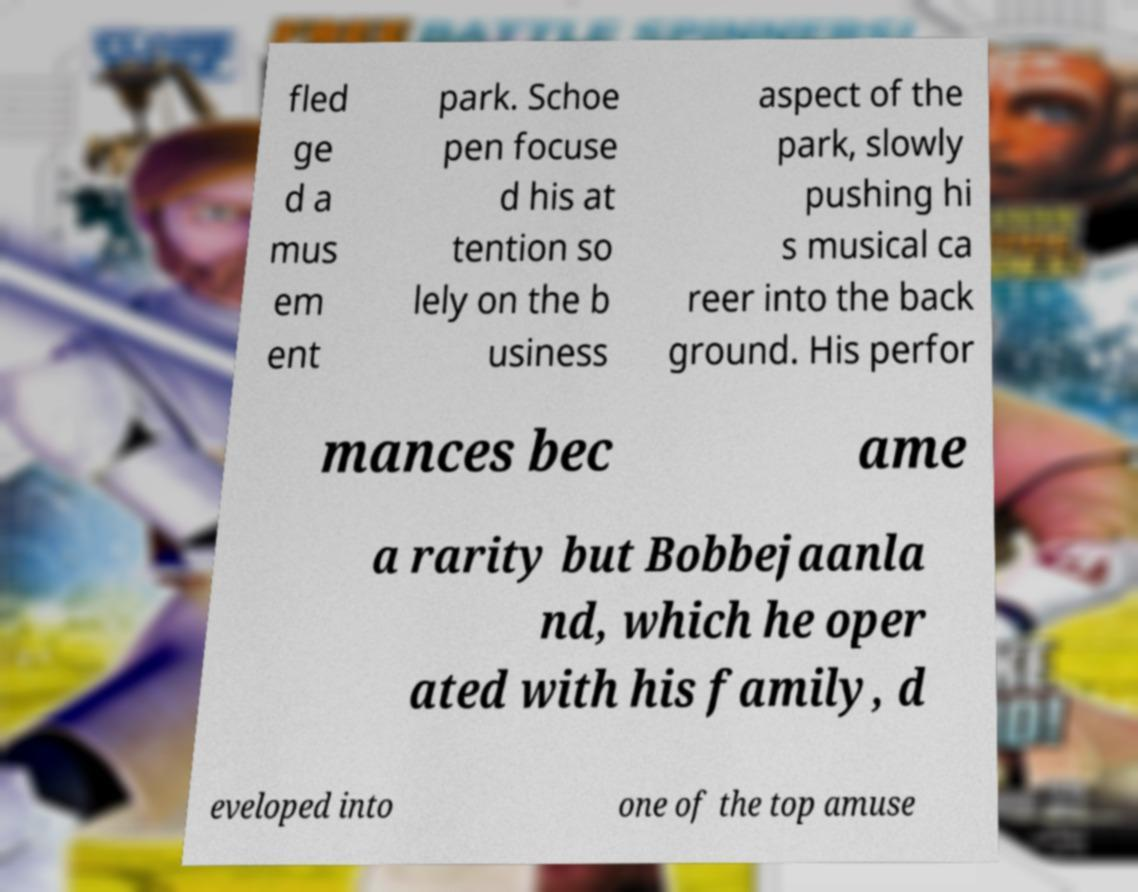What messages or text are displayed in this image? I need them in a readable, typed format. fled ge d a mus em ent park. Schoe pen focuse d his at tention so lely on the b usiness aspect of the park, slowly pushing hi s musical ca reer into the back ground. His perfor mances bec ame a rarity but Bobbejaanla nd, which he oper ated with his family, d eveloped into one of the top amuse 